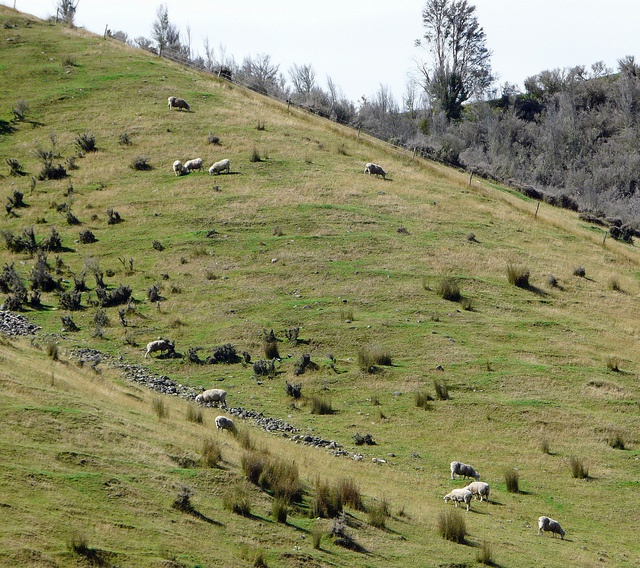Describe the objects in this image and their specific colors. I can see sheep in white, black, gray, darkgray, and lightgray tones, sheep in white, black, lightgray, gray, and darkgray tones, sheep in white, black, gray, darkgray, and lightgray tones, sheep in white, black, gray, darkgreen, and olive tones, and sheep in white, ivory, gray, black, and darkgray tones in this image. 